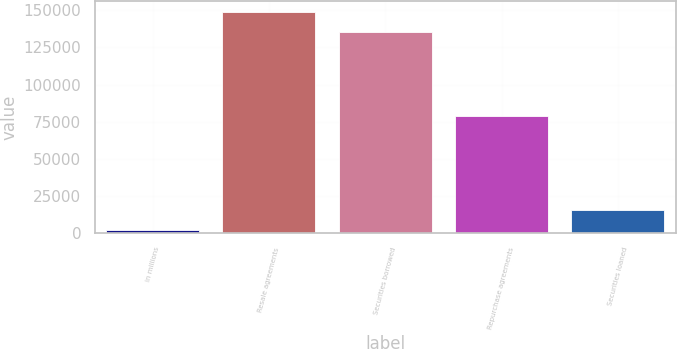<chart> <loc_0><loc_0><loc_500><loc_500><bar_chart><fcel>in millions<fcel>Resale agreements<fcel>Securities borrowed<fcel>Repurchase agreements<fcel>Securities loaned<nl><fcel>2018<fcel>149009<fcel>135285<fcel>78723<fcel>15742<nl></chart> 